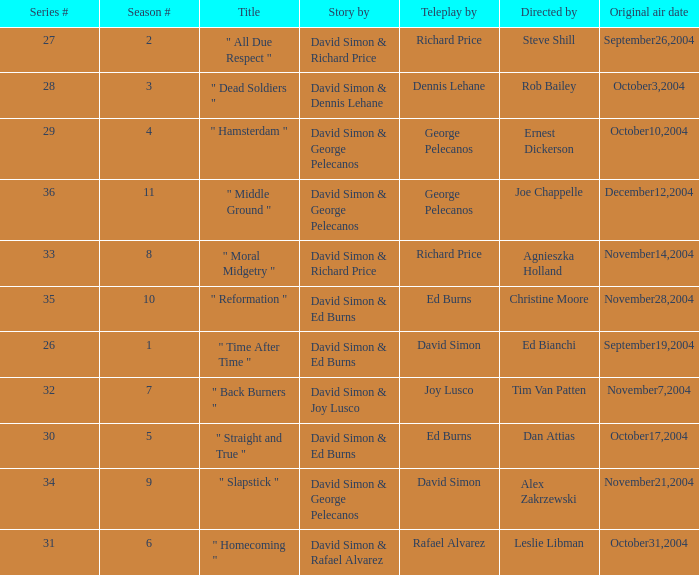Could you parse the entire table as a dict? {'header': ['Series #', 'Season #', 'Title', 'Story by', 'Teleplay by', 'Directed by', 'Original air date'], 'rows': [['27', '2', '" All Due Respect "', 'David Simon & Richard Price', 'Richard Price', 'Steve Shill', 'September26,2004'], ['28', '3', '" Dead Soldiers "', 'David Simon & Dennis Lehane', 'Dennis Lehane', 'Rob Bailey', 'October3,2004'], ['29', '4', '" Hamsterdam "', 'David Simon & George Pelecanos', 'George Pelecanos', 'Ernest Dickerson', 'October10,2004'], ['36', '11', '" Middle Ground "', 'David Simon & George Pelecanos', 'George Pelecanos', 'Joe Chappelle', 'December12,2004'], ['33', '8', '" Moral Midgetry "', 'David Simon & Richard Price', 'Richard Price', 'Agnieszka Holland', 'November14,2004'], ['35', '10', '" Reformation "', 'David Simon & Ed Burns', 'Ed Burns', 'Christine Moore', 'November28,2004'], ['26', '1', '" Time After Time "', 'David Simon & Ed Burns', 'David Simon', 'Ed Bianchi', 'September19,2004'], ['32', '7', '" Back Burners "', 'David Simon & Joy Lusco', 'Joy Lusco', 'Tim Van Patten', 'November7,2004'], ['30', '5', '" Straight and True "', 'David Simon & Ed Burns', 'Ed Burns', 'Dan Attias', 'October17,2004'], ['34', '9', '" Slapstick "', 'David Simon & George Pelecanos', 'David Simon', 'Alex Zakrzewski', 'November21,2004'], ['31', '6', '" Homecoming "', 'David Simon & Rafael Alvarez', 'Rafael Alvarez', 'Leslie Libman', 'October31,2004']]} What is the season # for a teleplay by Richard Price and the director is Steve Shill? 2.0. 